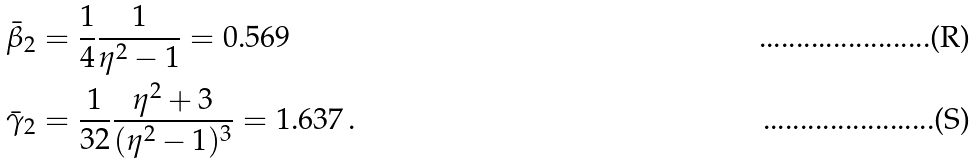<formula> <loc_0><loc_0><loc_500><loc_500>\bar { \beta } _ { 2 } & = \frac { 1 } { 4 } \frac { 1 } { \eta ^ { 2 } - 1 } = 0 . 5 6 9 \\ \bar { \gamma } _ { 2 } & = \frac { 1 } { 3 2 } \frac { \eta ^ { 2 } + 3 } { ( \eta ^ { 2 } - 1 ) ^ { 3 } } = 1 . 6 3 7 \, .</formula> 